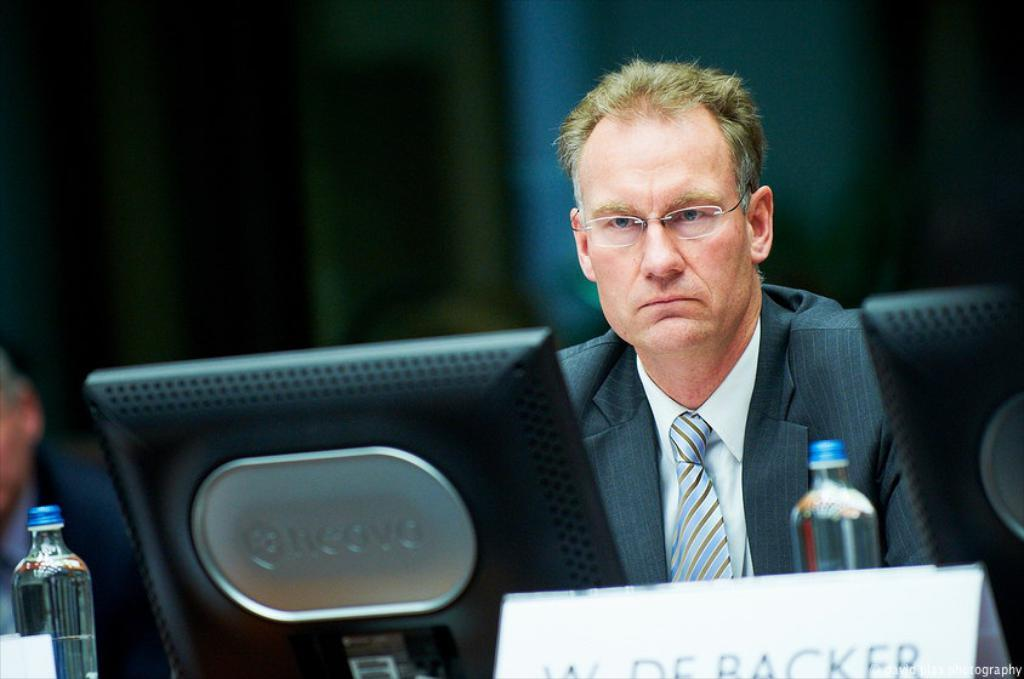Who is present in the image? There is a man in the image. What is the man doing in the image? The man is sitting on a chair and looking at a monitor. What can be seen on the table in the image? There is a bottle on the table in the image. What is the man wearing in the image? The man is wearing a coat, a tie, and spectacles. Can you see any visible veins on the man's hands in the image? There is no information about the man's hands or veins in the image, so it cannot be determined. What type of jelly is being used as a prop in the image? There is no jelly present in the image. 